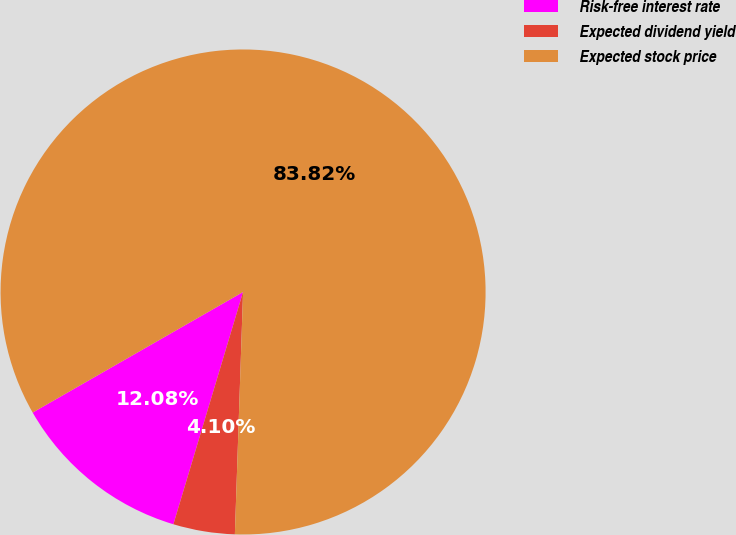Convert chart. <chart><loc_0><loc_0><loc_500><loc_500><pie_chart><fcel>Risk-free interest rate<fcel>Expected dividend yield<fcel>Expected stock price<nl><fcel>12.08%<fcel>4.1%<fcel>83.82%<nl></chart> 